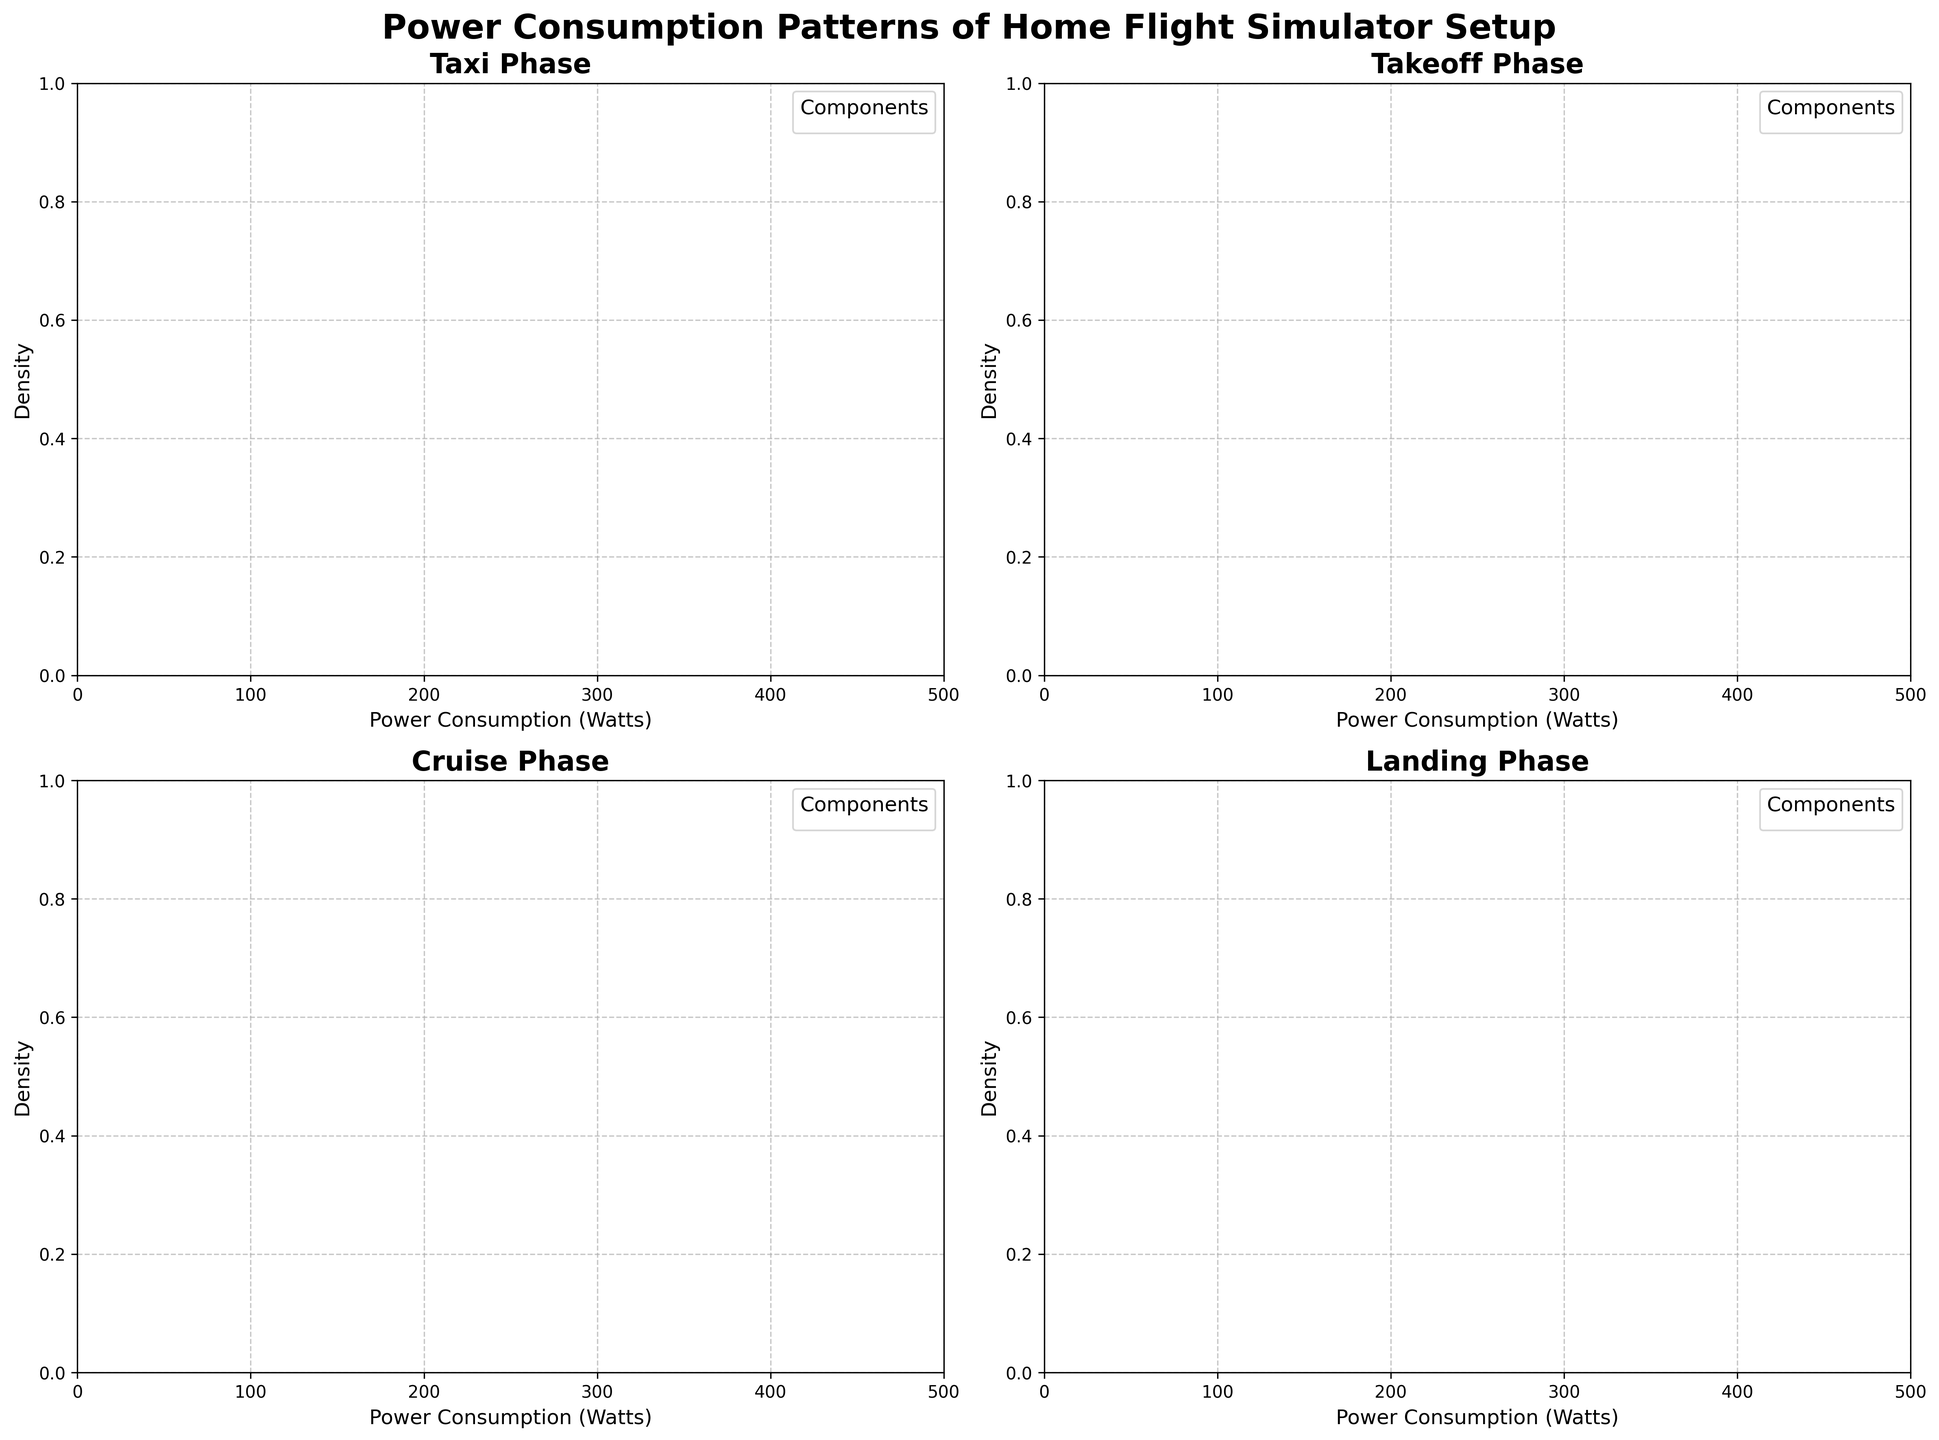What is the title of the figure? The title of the plot is usually displayed prominently at the top of the figure. In this case, it reads "Power Consumption Patterns of Home Flight Simulator Setup".
Answer: Power Consumption Patterns of Home Flight Simulator Setup Which flight phase shows the highest power consumption density for the Motion Platform? By analyzing the density plots for each phase, the phase with the highest peak in the density plot for the Motion Platform can be identified.
Answer: Takeoff How does the power consumption pattern for the Main Display compare between Cruise and Landing phases? To compare the patterns, look at the density curves for the Main Display in the Cruise and Landing subplots. The Landing phase has a slightly higher peak than the Cruise phase, indicating higher power consumption density.
Answer: Landing phase shows a slightly higher density Which component has the lowest maximum power consumption density during the Taxi phase? Observe the peaks of density plots for each component within the Taxi phase subplot. The Flight Controls component has the lowest peak.
Answer: Flight Controls What is the shape of the density plot for PC Hardware during the Takeoff phase? Analyze the curve shape for PC Hardware in the Takeoff phase subplot. The curve is broader and shows a significant peak, indicating a wider range of power consumption values with a concentrated high density.
Answer: Broad with a significant peak In which phase does the Secondary Displays component consume the least power on average? By comparing the density curves for the Secondary Displays in all phases, it's most spread out, indicating lower average power consumption in the Taxi phase.
Answer: Taxi Which component's power consumption density shows the most variation in the Landing phase? The component with the flattest, widest density curve in the Landing phase subplot shows the most variation. The Flight Controls' density curve is the flattest and widest.
Answer: Flight Controls During which flight phase does the PC Hardware component show the highest peak in power consumption density? Examine the density plots for the PC Hardware component across all phases. The Takeoff phase curve has the highest peak of all.
Answer: Takeoff What is the approximate power consumption range for the Secondary Displays in the Cruise phase? By looking at the start and end points of the density plot for Secondary Displays in the Cruise phase, the range can be estimated. It covers from around 150 to 300 Watts.
Answer: 150 to 300 Watts 